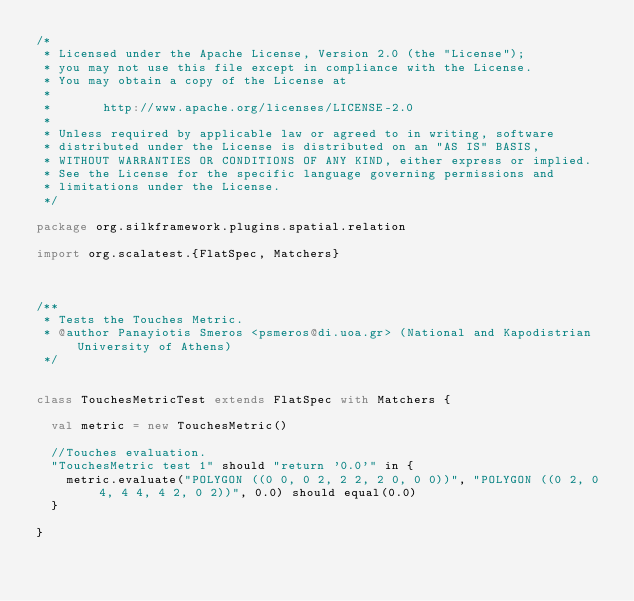<code> <loc_0><loc_0><loc_500><loc_500><_Scala_>/*
 * Licensed under the Apache License, Version 2.0 (the "License");
 * you may not use this file except in compliance with the License.
 * You may obtain a copy of the License at
 *
 *       http://www.apache.org/licenses/LICENSE-2.0
 *
 * Unless required by applicable law or agreed to in writing, software
 * distributed under the License is distributed on an "AS IS" BASIS,
 * WITHOUT WARRANTIES OR CONDITIONS OF ANY KIND, either express or implied.
 * See the License for the specific language governing permissions and
 * limitations under the License.
 */

package org.silkframework.plugins.spatial.relation

import org.scalatest.{FlatSpec, Matchers}



/**
 * Tests the Touches Metric.
 * @author Panayiotis Smeros <psmeros@di.uoa.gr> (National and Kapodistrian University of Athens)
 */


class TouchesMetricTest extends FlatSpec with Matchers {

  val metric = new TouchesMetric()

  //Touches evaluation.
  "TouchesMetric test 1" should "return '0.0'" in {
    metric.evaluate("POLYGON ((0 0, 0 2, 2 2, 2 0, 0 0))", "POLYGON ((0 2, 0 4, 4 4, 4 2, 0 2))", 0.0) should equal(0.0)
  }

}
</code> 